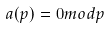<formula> <loc_0><loc_0><loc_500><loc_500>a ( p ) = 0 m o d p</formula> 